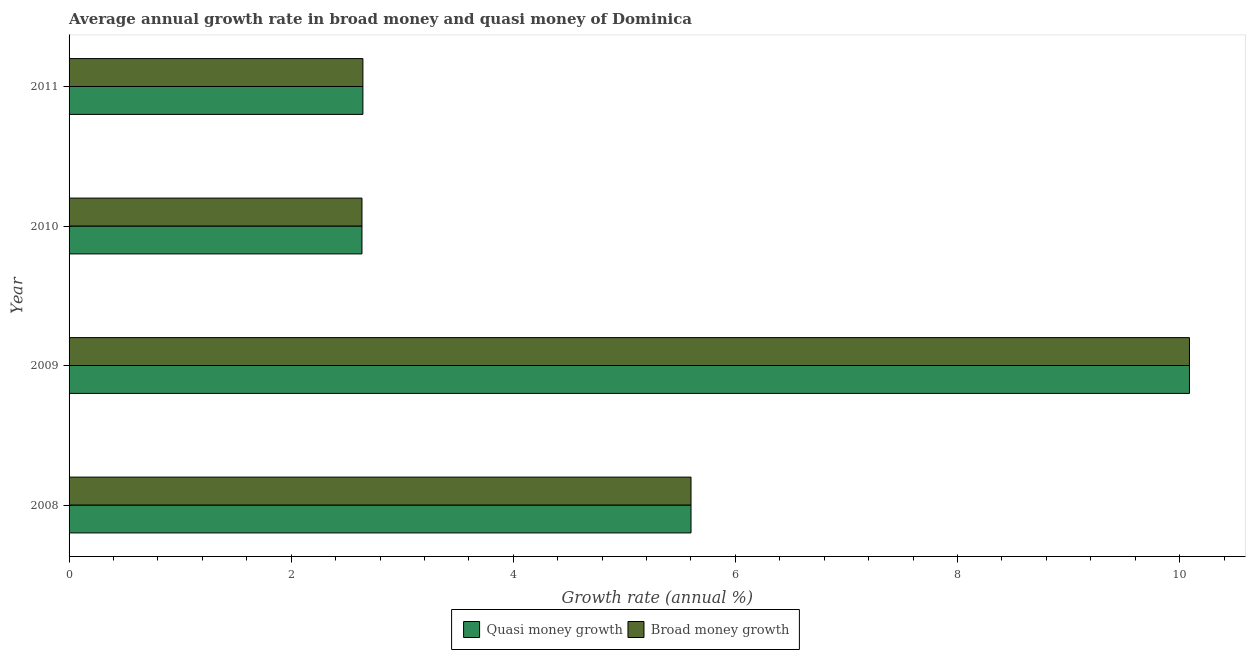How many different coloured bars are there?
Keep it short and to the point. 2. What is the label of the 1st group of bars from the top?
Your response must be concise. 2011. In how many cases, is the number of bars for a given year not equal to the number of legend labels?
Make the answer very short. 0. What is the annual growth rate in quasi money in 2008?
Ensure brevity in your answer.  5.6. Across all years, what is the maximum annual growth rate in broad money?
Your response must be concise. 10.09. Across all years, what is the minimum annual growth rate in broad money?
Give a very brief answer. 2.64. What is the total annual growth rate in quasi money in the graph?
Offer a terse response. 20.97. What is the difference between the annual growth rate in quasi money in 2009 and that in 2011?
Your answer should be very brief. 7.44. What is the difference between the annual growth rate in broad money in 2011 and the annual growth rate in quasi money in 2008?
Make the answer very short. -2.95. What is the average annual growth rate in broad money per year?
Offer a very short reply. 5.24. In how many years, is the annual growth rate in broad money greater than 0.8 %?
Ensure brevity in your answer.  4. What is the ratio of the annual growth rate in quasi money in 2009 to that in 2011?
Ensure brevity in your answer.  3.81. What is the difference between the highest and the second highest annual growth rate in broad money?
Ensure brevity in your answer.  4.49. What is the difference between the highest and the lowest annual growth rate in broad money?
Offer a very short reply. 7.45. Is the sum of the annual growth rate in broad money in 2009 and 2010 greater than the maximum annual growth rate in quasi money across all years?
Provide a short and direct response. Yes. What does the 2nd bar from the top in 2009 represents?
Give a very brief answer. Quasi money growth. What does the 2nd bar from the bottom in 2011 represents?
Offer a very short reply. Broad money growth. Does the graph contain any zero values?
Keep it short and to the point. No. Where does the legend appear in the graph?
Your answer should be very brief. Bottom center. What is the title of the graph?
Ensure brevity in your answer.  Average annual growth rate in broad money and quasi money of Dominica. What is the label or title of the X-axis?
Ensure brevity in your answer.  Growth rate (annual %). What is the label or title of the Y-axis?
Offer a very short reply. Year. What is the Growth rate (annual %) in Quasi money growth in 2008?
Make the answer very short. 5.6. What is the Growth rate (annual %) of Broad money growth in 2008?
Give a very brief answer. 5.6. What is the Growth rate (annual %) of Quasi money growth in 2009?
Ensure brevity in your answer.  10.09. What is the Growth rate (annual %) in Broad money growth in 2009?
Make the answer very short. 10.09. What is the Growth rate (annual %) in Quasi money growth in 2010?
Make the answer very short. 2.64. What is the Growth rate (annual %) of Broad money growth in 2010?
Make the answer very short. 2.64. What is the Growth rate (annual %) in Quasi money growth in 2011?
Your answer should be very brief. 2.65. What is the Growth rate (annual %) of Broad money growth in 2011?
Your response must be concise. 2.65. Across all years, what is the maximum Growth rate (annual %) in Quasi money growth?
Keep it short and to the point. 10.09. Across all years, what is the maximum Growth rate (annual %) in Broad money growth?
Your answer should be very brief. 10.09. Across all years, what is the minimum Growth rate (annual %) in Quasi money growth?
Give a very brief answer. 2.64. Across all years, what is the minimum Growth rate (annual %) of Broad money growth?
Keep it short and to the point. 2.64. What is the total Growth rate (annual %) in Quasi money growth in the graph?
Offer a very short reply. 20.97. What is the total Growth rate (annual %) in Broad money growth in the graph?
Provide a succinct answer. 20.97. What is the difference between the Growth rate (annual %) of Quasi money growth in 2008 and that in 2009?
Provide a succinct answer. -4.49. What is the difference between the Growth rate (annual %) in Broad money growth in 2008 and that in 2009?
Give a very brief answer. -4.49. What is the difference between the Growth rate (annual %) of Quasi money growth in 2008 and that in 2010?
Your answer should be very brief. 2.96. What is the difference between the Growth rate (annual %) of Broad money growth in 2008 and that in 2010?
Offer a very short reply. 2.96. What is the difference between the Growth rate (annual %) of Quasi money growth in 2008 and that in 2011?
Ensure brevity in your answer.  2.95. What is the difference between the Growth rate (annual %) in Broad money growth in 2008 and that in 2011?
Your response must be concise. 2.95. What is the difference between the Growth rate (annual %) in Quasi money growth in 2009 and that in 2010?
Provide a succinct answer. 7.45. What is the difference between the Growth rate (annual %) of Broad money growth in 2009 and that in 2010?
Ensure brevity in your answer.  7.45. What is the difference between the Growth rate (annual %) in Quasi money growth in 2009 and that in 2011?
Make the answer very short. 7.44. What is the difference between the Growth rate (annual %) in Broad money growth in 2009 and that in 2011?
Provide a short and direct response. 7.44. What is the difference between the Growth rate (annual %) of Quasi money growth in 2010 and that in 2011?
Keep it short and to the point. -0.01. What is the difference between the Growth rate (annual %) in Broad money growth in 2010 and that in 2011?
Your answer should be compact. -0.01. What is the difference between the Growth rate (annual %) in Quasi money growth in 2008 and the Growth rate (annual %) in Broad money growth in 2009?
Your answer should be very brief. -4.49. What is the difference between the Growth rate (annual %) in Quasi money growth in 2008 and the Growth rate (annual %) in Broad money growth in 2010?
Provide a succinct answer. 2.96. What is the difference between the Growth rate (annual %) of Quasi money growth in 2008 and the Growth rate (annual %) of Broad money growth in 2011?
Your answer should be compact. 2.95. What is the difference between the Growth rate (annual %) in Quasi money growth in 2009 and the Growth rate (annual %) in Broad money growth in 2010?
Provide a short and direct response. 7.45. What is the difference between the Growth rate (annual %) of Quasi money growth in 2009 and the Growth rate (annual %) of Broad money growth in 2011?
Make the answer very short. 7.44. What is the difference between the Growth rate (annual %) in Quasi money growth in 2010 and the Growth rate (annual %) in Broad money growth in 2011?
Ensure brevity in your answer.  -0.01. What is the average Growth rate (annual %) of Quasi money growth per year?
Your answer should be compact. 5.24. What is the average Growth rate (annual %) in Broad money growth per year?
Your answer should be compact. 5.24. In the year 2008, what is the difference between the Growth rate (annual %) in Quasi money growth and Growth rate (annual %) in Broad money growth?
Your answer should be compact. 0. In the year 2009, what is the difference between the Growth rate (annual %) of Quasi money growth and Growth rate (annual %) of Broad money growth?
Offer a terse response. 0. In the year 2010, what is the difference between the Growth rate (annual %) in Quasi money growth and Growth rate (annual %) in Broad money growth?
Your answer should be very brief. 0. In the year 2011, what is the difference between the Growth rate (annual %) in Quasi money growth and Growth rate (annual %) in Broad money growth?
Your response must be concise. 0. What is the ratio of the Growth rate (annual %) in Quasi money growth in 2008 to that in 2009?
Your answer should be very brief. 0.56. What is the ratio of the Growth rate (annual %) of Broad money growth in 2008 to that in 2009?
Your answer should be compact. 0.56. What is the ratio of the Growth rate (annual %) of Quasi money growth in 2008 to that in 2010?
Ensure brevity in your answer.  2.12. What is the ratio of the Growth rate (annual %) of Broad money growth in 2008 to that in 2010?
Your response must be concise. 2.12. What is the ratio of the Growth rate (annual %) in Quasi money growth in 2008 to that in 2011?
Keep it short and to the point. 2.12. What is the ratio of the Growth rate (annual %) in Broad money growth in 2008 to that in 2011?
Your response must be concise. 2.12. What is the ratio of the Growth rate (annual %) of Quasi money growth in 2009 to that in 2010?
Ensure brevity in your answer.  3.83. What is the ratio of the Growth rate (annual %) in Broad money growth in 2009 to that in 2010?
Provide a succinct answer. 3.83. What is the ratio of the Growth rate (annual %) of Quasi money growth in 2009 to that in 2011?
Your response must be concise. 3.81. What is the ratio of the Growth rate (annual %) in Broad money growth in 2009 to that in 2011?
Provide a succinct answer. 3.81. What is the ratio of the Growth rate (annual %) of Quasi money growth in 2010 to that in 2011?
Make the answer very short. 1. What is the difference between the highest and the second highest Growth rate (annual %) of Quasi money growth?
Your response must be concise. 4.49. What is the difference between the highest and the second highest Growth rate (annual %) of Broad money growth?
Make the answer very short. 4.49. What is the difference between the highest and the lowest Growth rate (annual %) of Quasi money growth?
Give a very brief answer. 7.45. What is the difference between the highest and the lowest Growth rate (annual %) in Broad money growth?
Give a very brief answer. 7.45. 